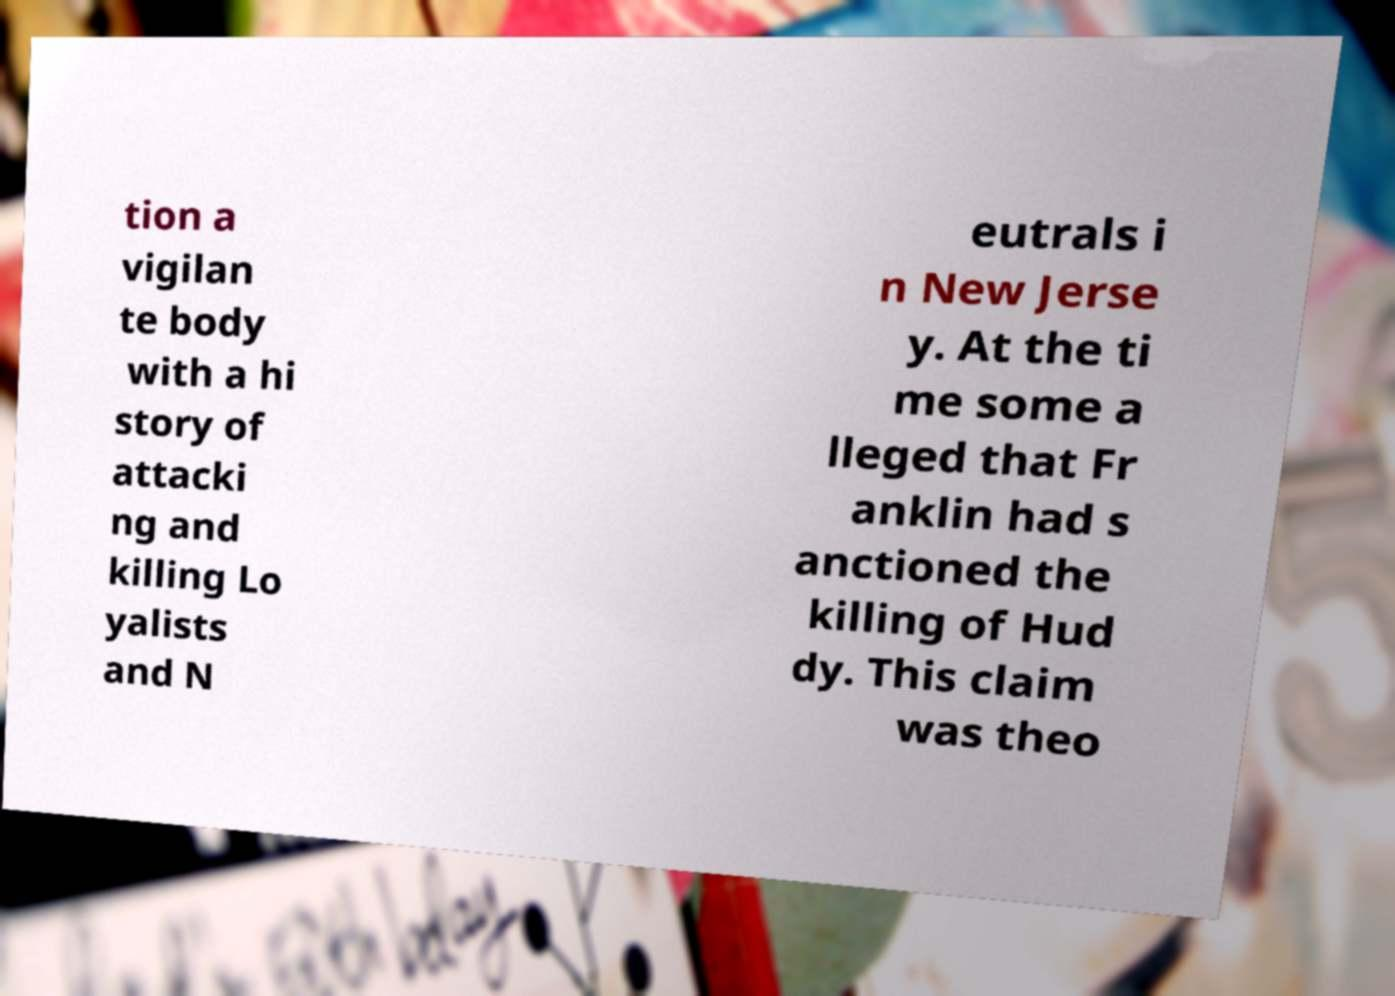I need the written content from this picture converted into text. Can you do that? tion a vigilan te body with a hi story of attacki ng and killing Lo yalists and N eutrals i n New Jerse y. At the ti me some a lleged that Fr anklin had s anctioned the killing of Hud dy. This claim was theo 